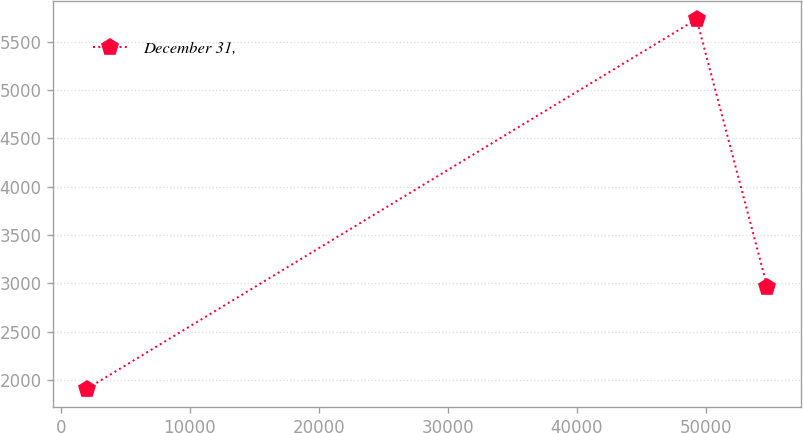Convert chart. <chart><loc_0><loc_0><loc_500><loc_500><line_chart><ecel><fcel>December 31,<nl><fcel>2066.8<fcel>1914.51<nl><fcel>49301.9<fcel>5732.01<nl><fcel>54791.9<fcel>2958.62<nl></chart> 